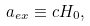<formula> <loc_0><loc_0><loc_500><loc_500>a _ { e x } \equiv c H _ { 0 } ,</formula> 